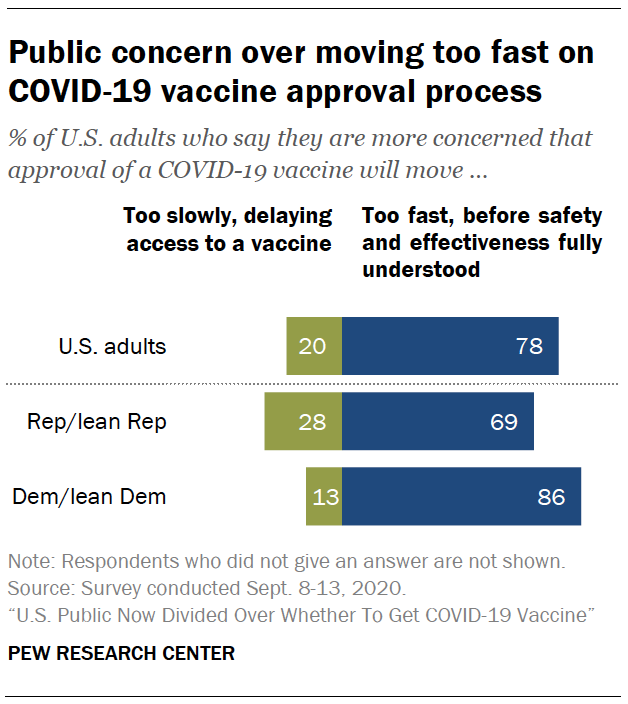Highlight a few significant elements in this photo. The navy blue bar is always dominant over the green bar. The difference between the median values of navy blue and green bars is 58. 